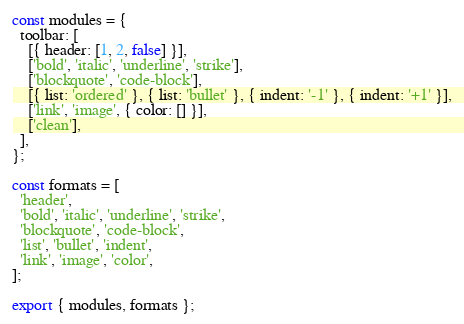<code> <loc_0><loc_0><loc_500><loc_500><_JavaScript_>const modules = {
  toolbar: [
    [{ header: [1, 2, false] }],
    ['bold', 'italic', 'underline', 'strike'],
    ['blockquote', 'code-block'],
    [{ list: 'ordered' }, { list: 'bullet' }, { indent: '-1' }, { indent: '+1' }],
    ['link', 'image', { color: [] }],
    ['clean'],
  ],
};

const formats = [
  'header',
  'bold', 'italic', 'underline', 'strike',
  'blockquote', 'code-block',
  'list', 'bullet', 'indent',
  'link', 'image', 'color',
];

export { modules, formats };
</code> 